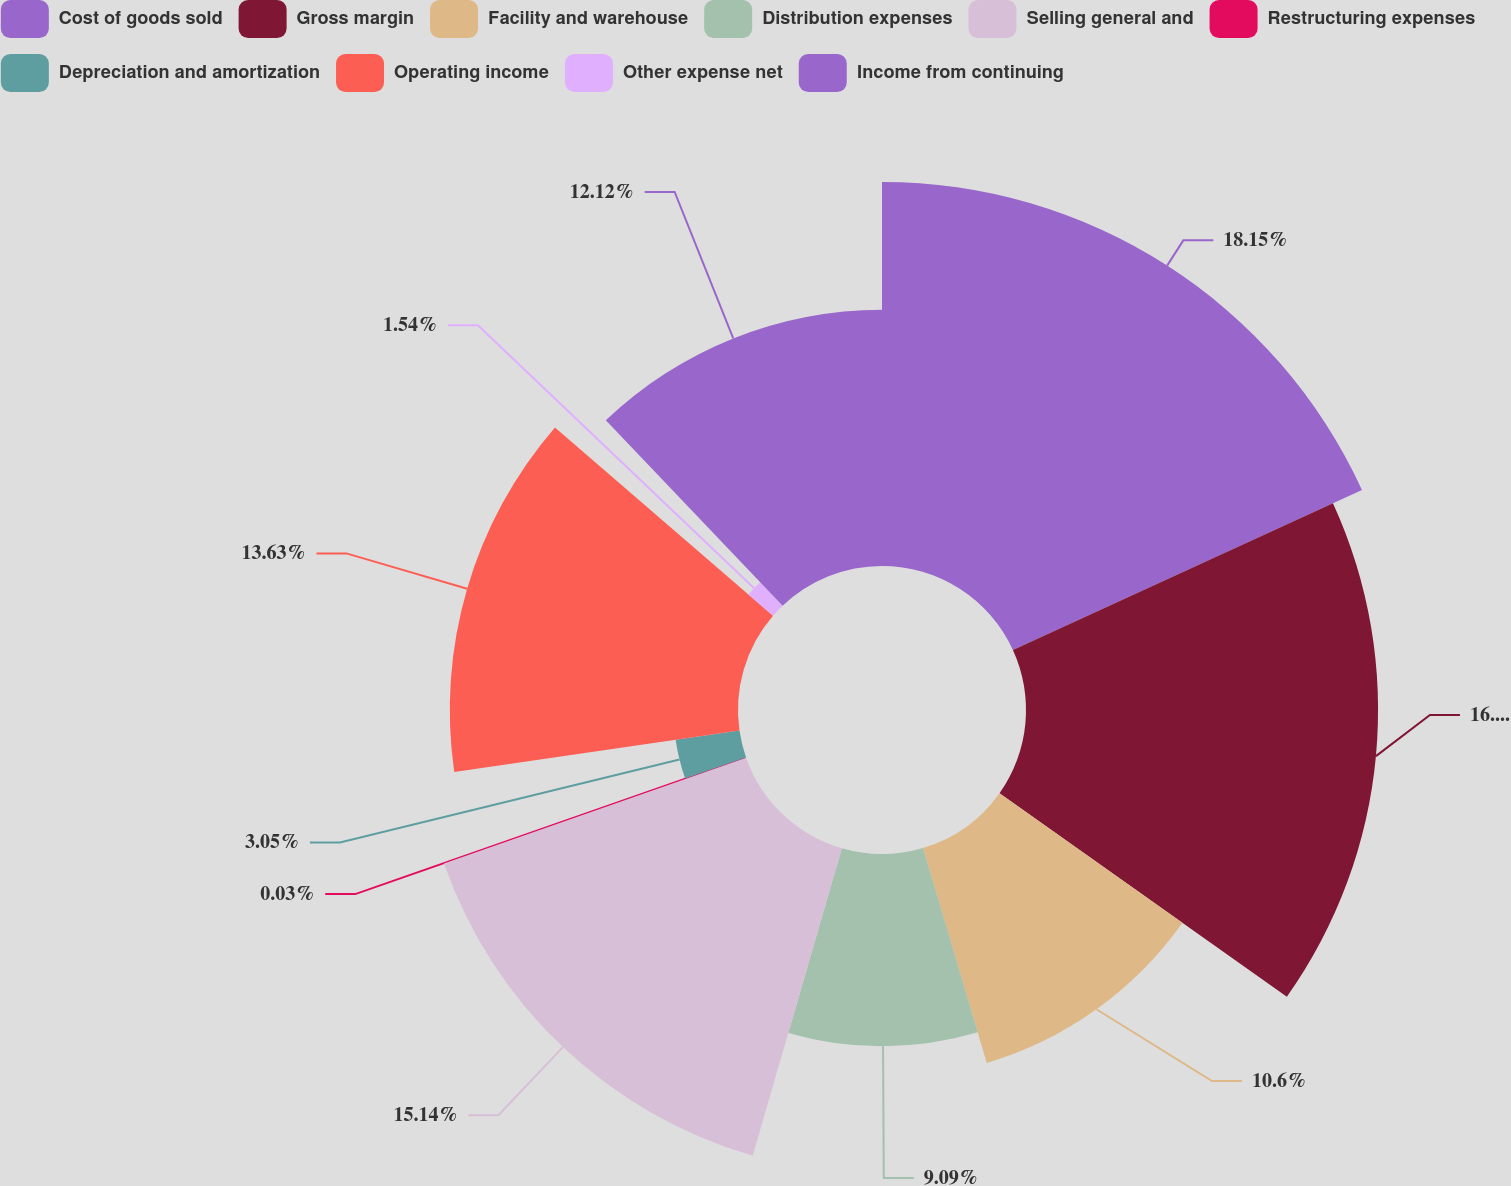Convert chart. <chart><loc_0><loc_0><loc_500><loc_500><pie_chart><fcel>Cost of goods sold<fcel>Gross margin<fcel>Facility and warehouse<fcel>Distribution expenses<fcel>Selling general and<fcel>Restructuring expenses<fcel>Depreciation and amortization<fcel>Operating income<fcel>Other expense net<fcel>Income from continuing<nl><fcel>18.16%<fcel>16.65%<fcel>10.6%<fcel>9.09%<fcel>15.14%<fcel>0.03%<fcel>3.05%<fcel>13.63%<fcel>1.54%<fcel>12.12%<nl></chart> 